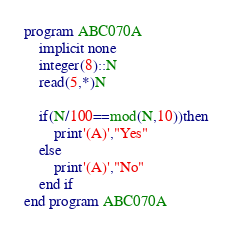Convert code to text. <code><loc_0><loc_0><loc_500><loc_500><_FORTRAN_>program ABC070A
    implicit none
    integer(8)::N
    read(5,*)N

    if(N/100==mod(N,10))then
        print'(A)',"Yes"
    else
        print'(A)',"No"
    end if
end program ABC070A</code> 